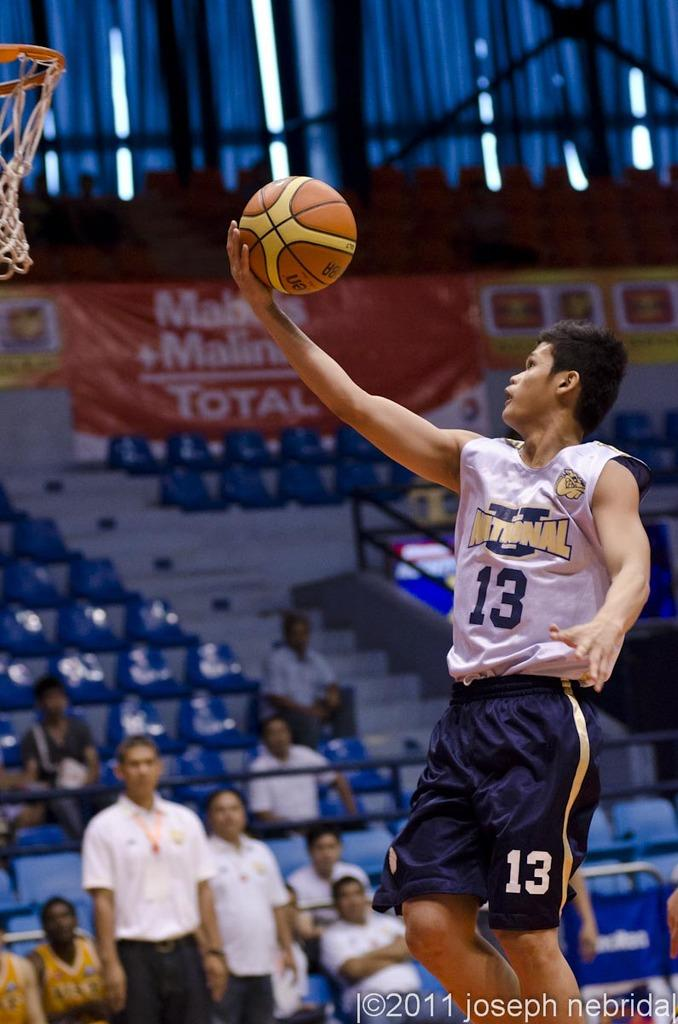What is the main subject in the center of the image? There is a person holding a ball in the center of the image. What are the people at the bottom of the image doing? The people sitting in chairs at the bottom of the image. Can you describe the background of the image? There are chairs visible in the background of the image. What type of vest is the spy wearing in the image? There is no spy or vest present in the image. How many bulbs are visible in the image? There are no bulbs visible in the image. 